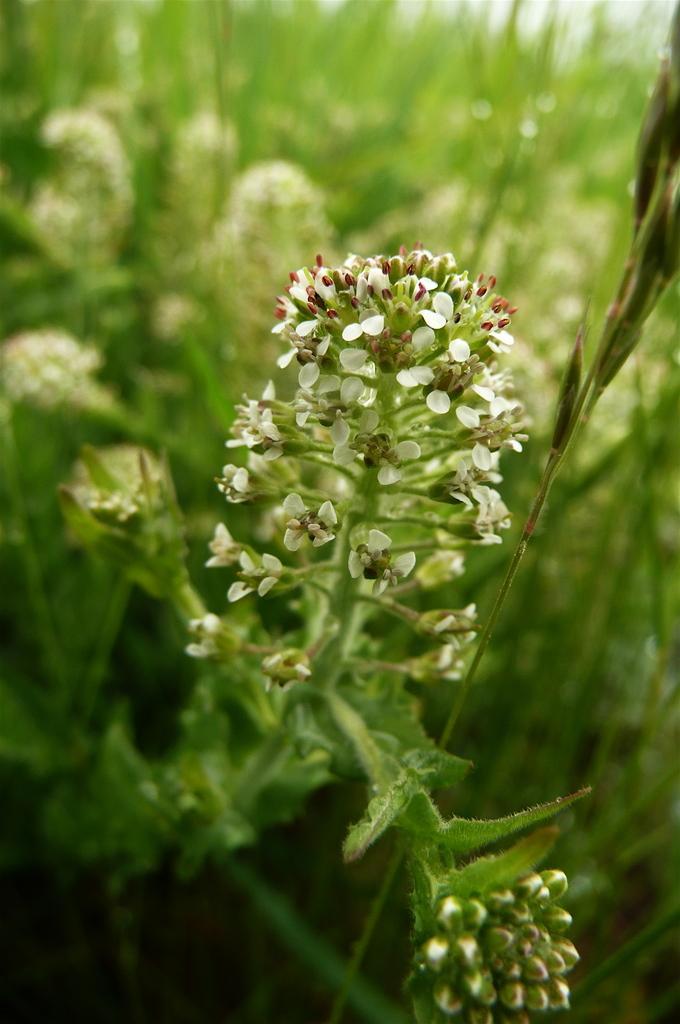Describe this image in one or two sentences. These are the flowers of a plant. 